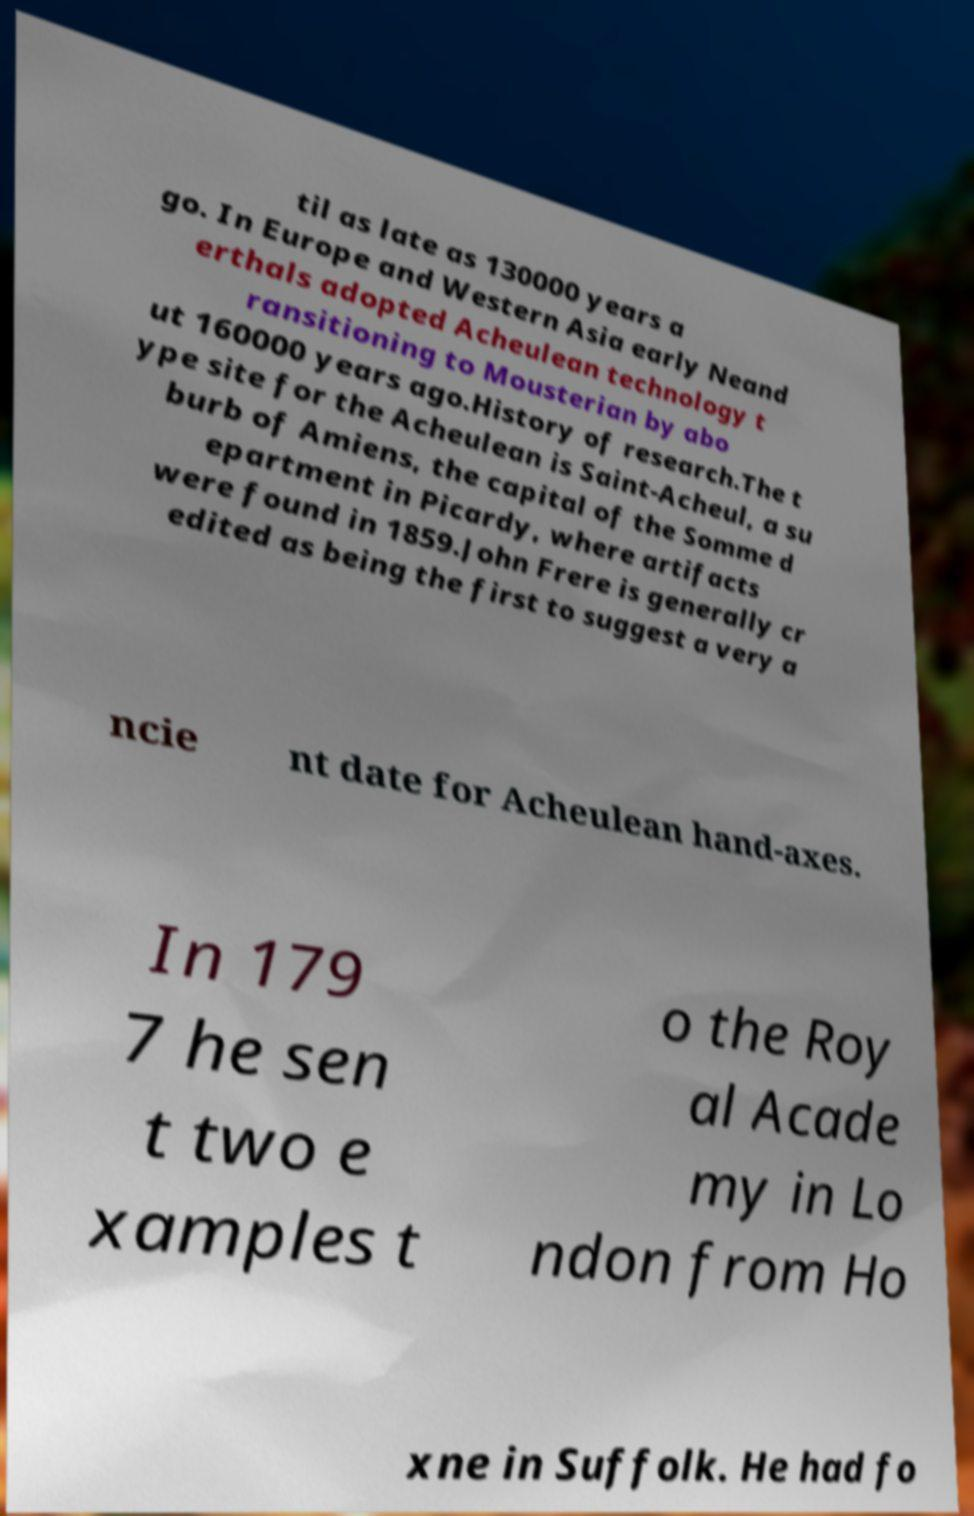Could you extract and type out the text from this image? til as late as 130000 years a go. In Europe and Western Asia early Neand erthals adopted Acheulean technology t ransitioning to Mousterian by abo ut 160000 years ago.History of research.The t ype site for the Acheulean is Saint-Acheul, a su burb of Amiens, the capital of the Somme d epartment in Picardy, where artifacts were found in 1859.John Frere is generally cr edited as being the first to suggest a very a ncie nt date for Acheulean hand-axes. In 179 7 he sen t two e xamples t o the Roy al Acade my in Lo ndon from Ho xne in Suffolk. He had fo 